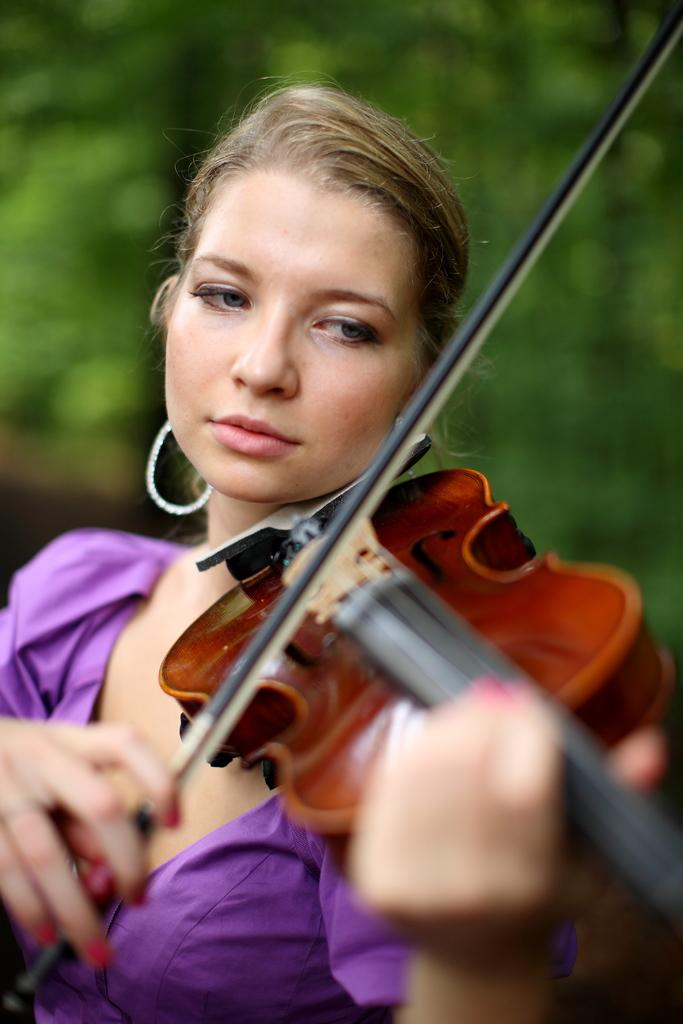What is the main subject of the image? There is a person in the image. What is the person doing in the image? The person is playing a musical instrument. Can you describe the background of the image? The background of the image is blurred. What type of lunch is the person eating in the image? There is no indication in the image that the person is eating lunch, as the focus is on the person playing a musical instrument. 